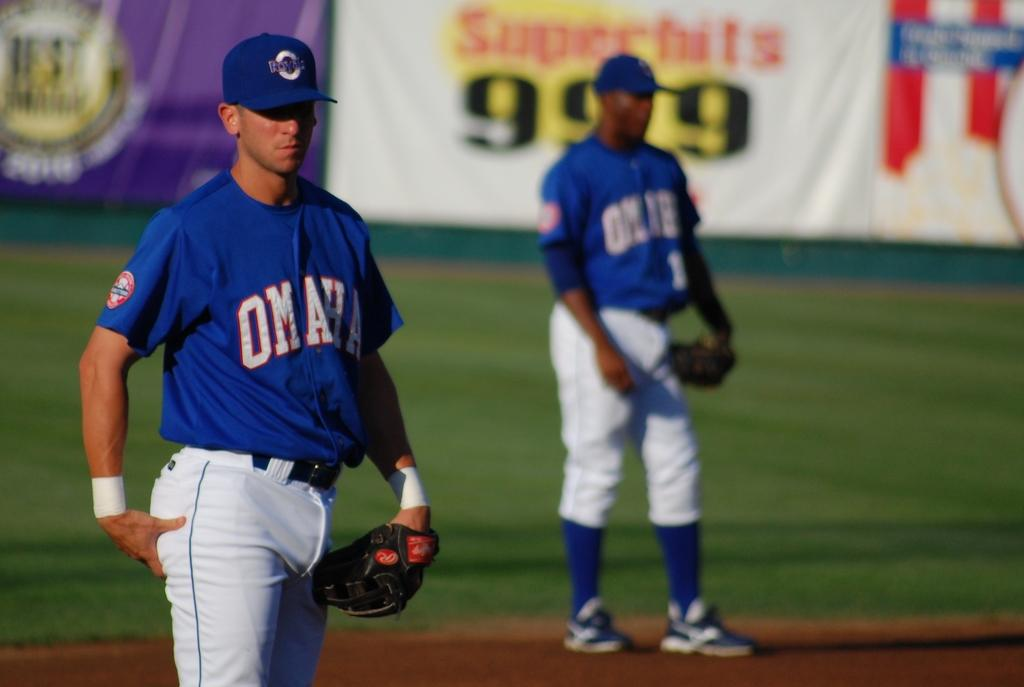<image>
Create a compact narrative representing the image presented. two blue colored omaha jersey players standing in front of the banner 999 